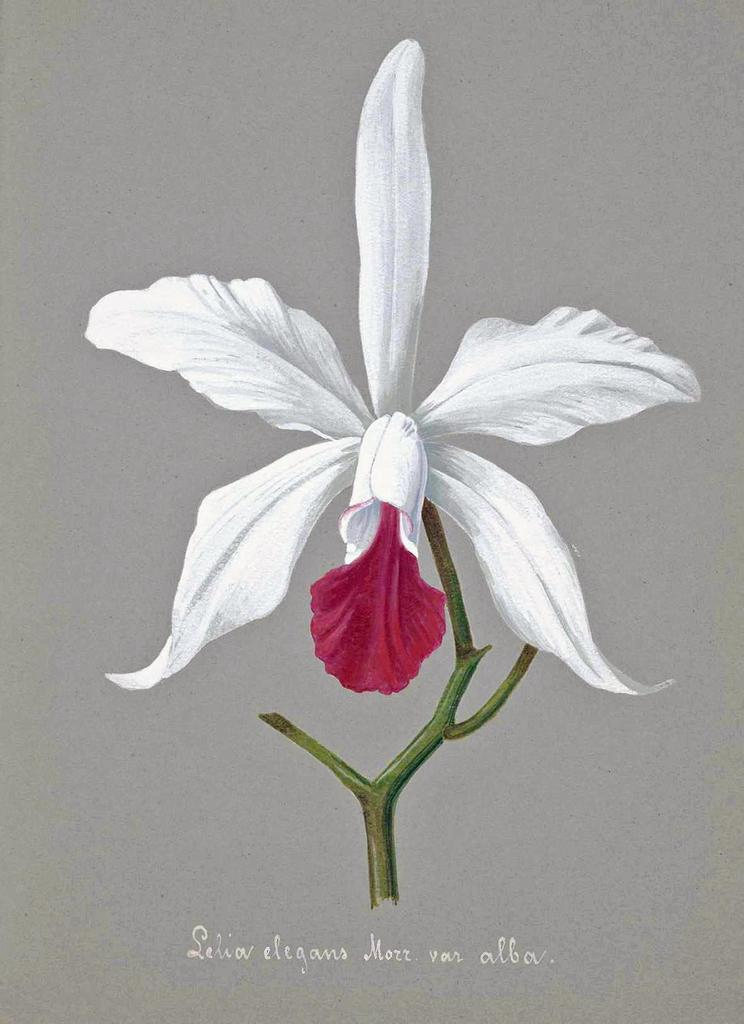What type of flower is in the image? There is a white color flower in the image. Can you describe the flower's structure? The flower has a stem. What else is present in the image besides the flower? There is text in the image. What is the color of the background in the image? The background of the image is grey in color. What type of polish is being applied to the flower in the image? There is no polish being applied to the flower in the image; it is a photograph of a flower with text and a grey background. 